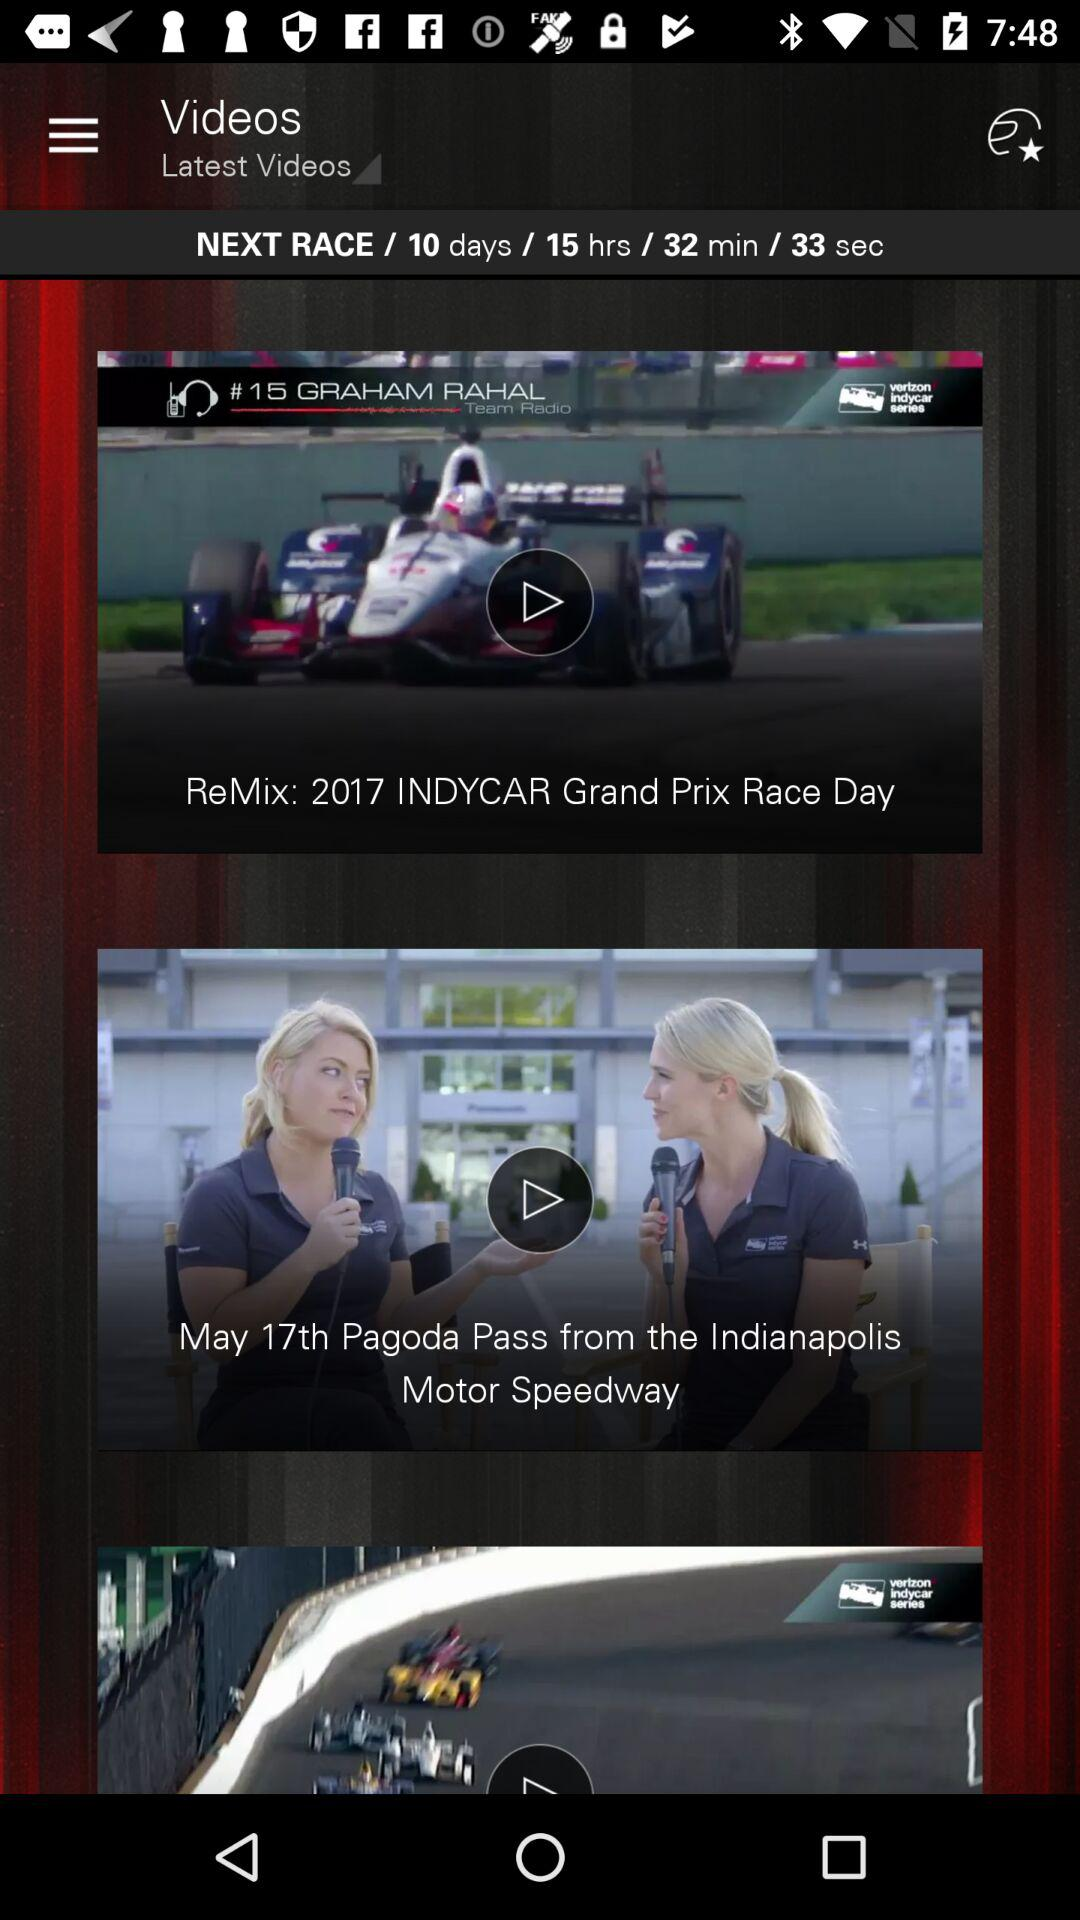What year is mentioned for "INDYCAR Grand Prix Race Day"? The year that is mentioned for "INDYCAR Grand Prix Race Day" is 2017. 